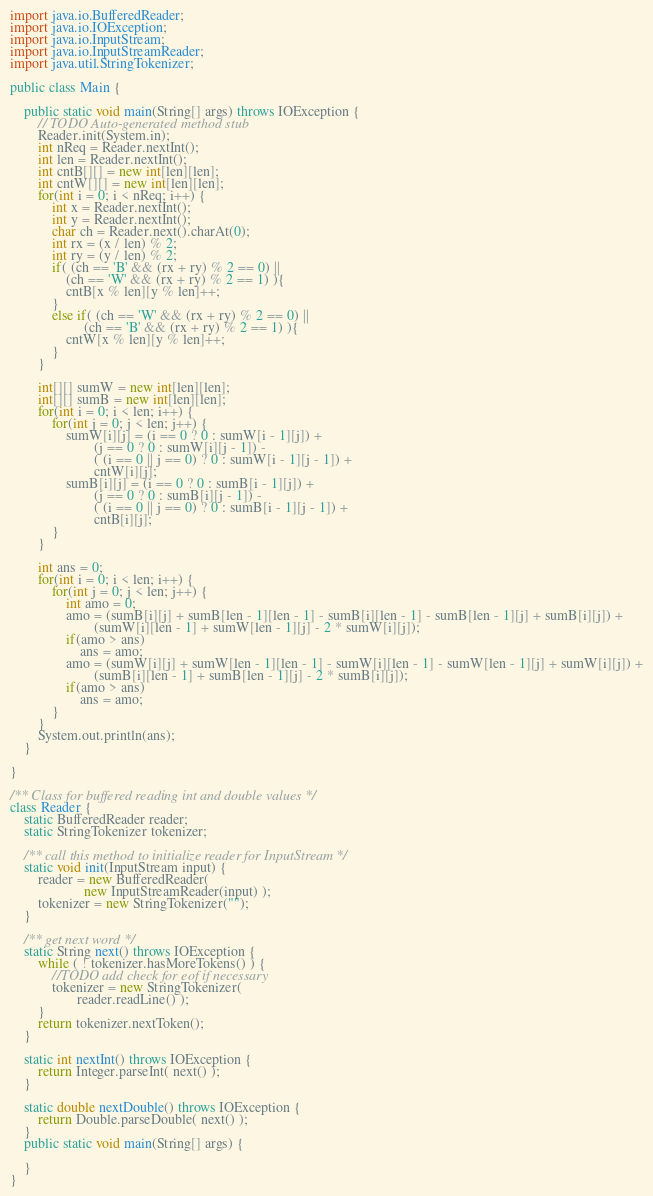<code> <loc_0><loc_0><loc_500><loc_500><_Java_>

import java.io.BufferedReader;
import java.io.IOException;
import java.io.InputStream;
import java.io.InputStreamReader;
import java.util.StringTokenizer;

public class Main {

	public static void main(String[] args) throws IOException {
		// TODO Auto-generated method stub
		Reader.init(System.in);
		int nReq = Reader.nextInt();
		int len = Reader.nextInt();
		int cntB[][] = new int[len][len];
		int cntW[][] = new int[len][len];
		for(int i = 0; i < nReq; i++) {
			int x = Reader.nextInt();
			int y = Reader.nextInt();
			char ch = Reader.next().charAt(0);
			int rx = (x / len) % 2;
			int ry = (y / len) % 2;
			if( (ch == 'B' && (rx + ry) % 2 == 0) ||
				(ch == 'W' && (rx + ry) % 2 == 1) ){
				cntB[x % len][y % len]++;
			}
			else if( (ch == 'W' && (rx + ry) % 2 == 0) || 
					 (ch == 'B' && (rx + ry) % 2 == 1) ){
				cntW[x % len][y % len]++;
			}
		}

		int[][] sumW = new int[len][len];
		int[][] sumB = new int[len][len];
		for(int i = 0; i < len; i++) {
			for(int j = 0; j < len; j++) {
				sumW[i][j] = (i == 0 ? 0 : sumW[i - 1][j]) + 
						(j == 0 ? 0 : sumW[i][j - 1]) - 
						( (i == 0 || j == 0) ? 0 : sumW[i - 1][j - 1]) + 
						cntW[i][j];
				sumB[i][j] = (i == 0 ? 0 : sumB[i - 1][j]) + 
						(j == 0 ? 0 : sumB[i][j - 1]) - 
						( (i == 0 || j == 0) ? 0 : sumB[i - 1][j - 1]) + 
						cntB[i][j];
			}
		}

		int ans = 0;
		for(int i = 0; i < len; i++) {
			for(int j = 0; j < len; j++) {
				int amo = 0;
				amo = (sumB[i][j] + sumB[len - 1][len - 1] - sumB[i][len - 1] - sumB[len - 1][j] + sumB[i][j]) +
						(sumW[i][len - 1] + sumW[len - 1][j] - 2 * sumW[i][j]);
				if(amo > ans)
					ans = amo;
				amo = (sumW[i][j] + sumW[len - 1][len - 1] - sumW[i][len - 1] - sumW[len - 1][j] + sumW[i][j]) +
						(sumB[i][len - 1] + sumB[len - 1][j] - 2 * sumB[i][j]);
				if(amo > ans)
					ans = amo;
			}
		}
		System.out.println(ans);
	}

}

/** Class for buffered reading int and double values */
class Reader {
    static BufferedReader reader;
    static StringTokenizer tokenizer;

    /** call this method to initialize reader for InputStream */
    static void init(InputStream input) {
        reader = new BufferedReader(
                     new InputStreamReader(input) );
        tokenizer = new StringTokenizer("");
    }

    /** get next word */
    static String next() throws IOException {
        while ( ! tokenizer.hasMoreTokens() ) {
            //TODO add check for eof if necessary
            tokenizer = new StringTokenizer(
                   reader.readLine() );
        }
        return tokenizer.nextToken();
    }

    static int nextInt() throws IOException {
        return Integer.parseInt( next() );
    }
	
    static double nextDouble() throws IOException {
        return Double.parseDouble( next() );
    }
    public static void main(String[] args) {
    	
    }
}</code> 